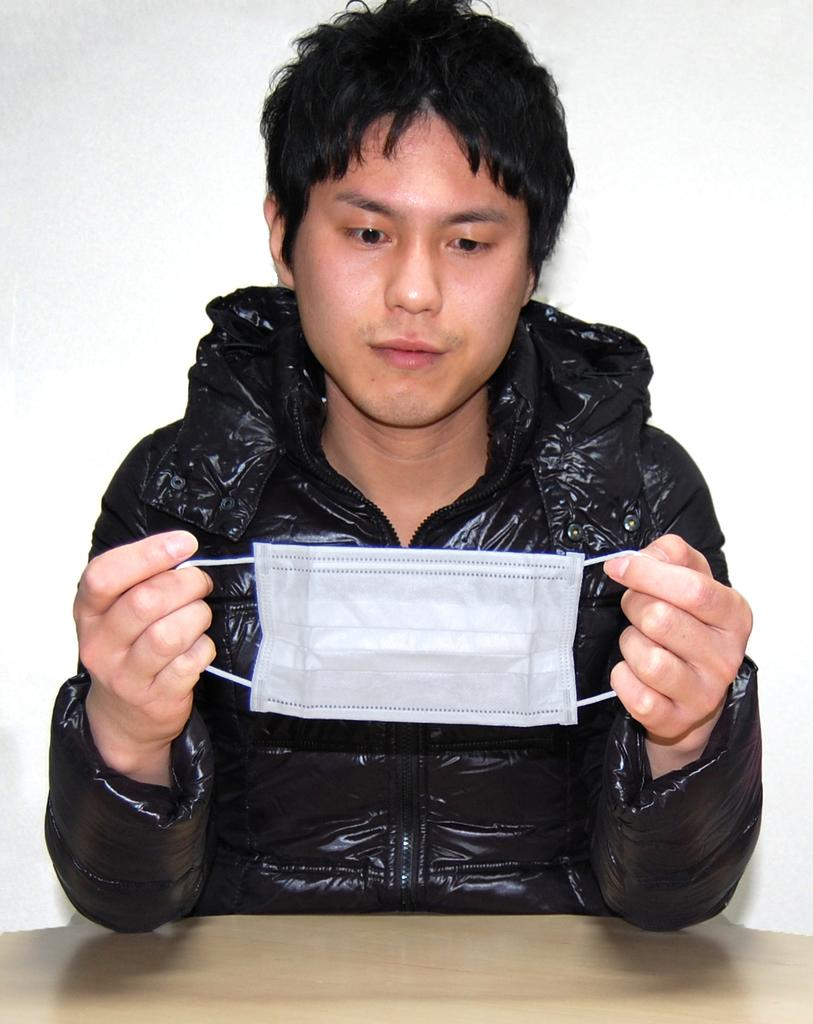What is the person in the image doing? The person is sitting at the table in the image. What can be seen behind the person? There is a wall in the background of the image. What type of cork is being used to secure the scene in the image? There is no cork present in the image, nor is there any indication of a scene being secured. 